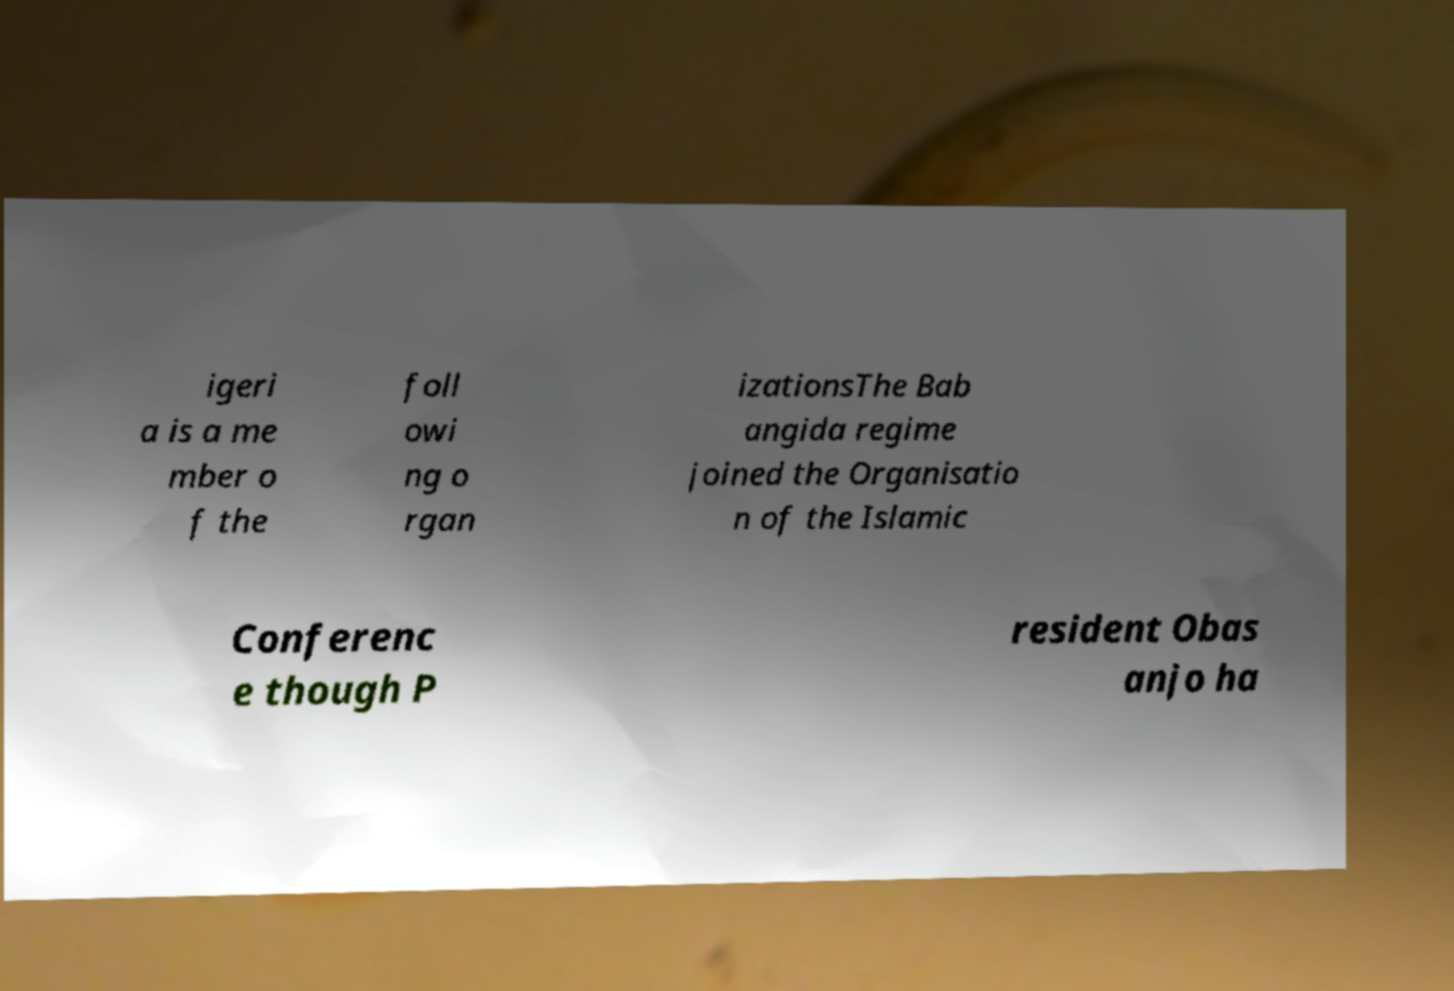Please read and relay the text visible in this image. What does it say? igeri a is a me mber o f the foll owi ng o rgan izationsThe Bab angida regime joined the Organisatio n of the Islamic Conferenc e though P resident Obas anjo ha 